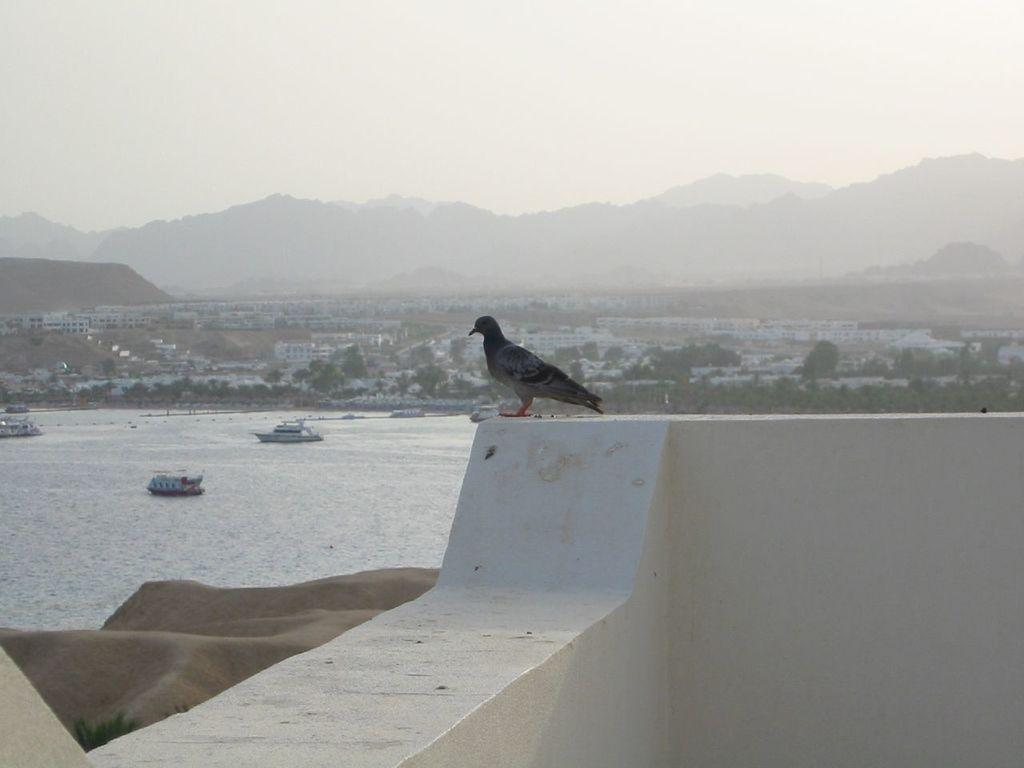What animal can be seen on the wall in the image? There is a pigeon on the wall in the image. What type of structures are visible in the image? There are houses visible in the image. What type of vegetation is present in the image? There are trees in the image. What type of watercraft can be seen in the image? There are boats on a river in the image. What part of the natural environment is visible in the image? The sky is visible in the image. What type of wine is being served at the event in the image? There is no event or wine present in the image; it features a pigeon on a wall, houses, trees, boats, and the sky. 